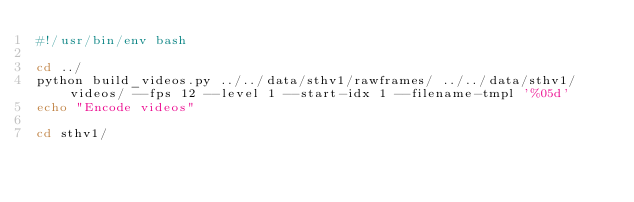<code> <loc_0><loc_0><loc_500><loc_500><_Bash_>#!/usr/bin/env bash

cd ../
python build_videos.py ../../data/sthv1/rawframes/ ../../data/sthv1/videos/ --fps 12 --level 1 --start-idx 1 --filename-tmpl '%05d'
echo "Encode videos"

cd sthv1/
</code> 